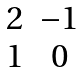Convert formula to latex. <formula><loc_0><loc_0><loc_500><loc_500>\begin{matrix} 2 & - 1 \\ 1 & 0 \end{matrix}</formula> 